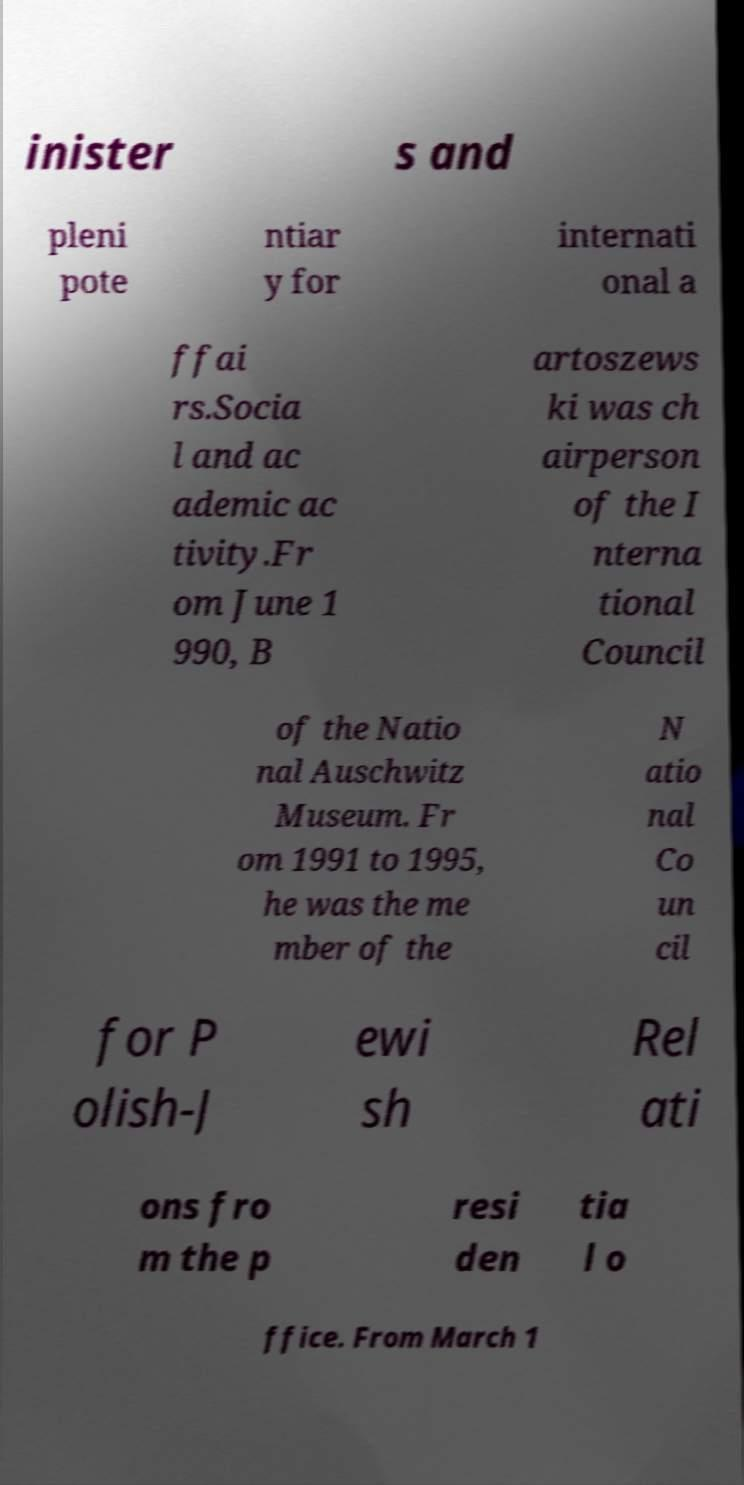Please read and relay the text visible in this image. What does it say? inister s and pleni pote ntiar y for internati onal a ffai rs.Socia l and ac ademic ac tivity.Fr om June 1 990, B artoszews ki was ch airperson of the I nterna tional Council of the Natio nal Auschwitz Museum. Fr om 1991 to 1995, he was the me mber of the N atio nal Co un cil for P olish-J ewi sh Rel ati ons fro m the p resi den tia l o ffice. From March 1 